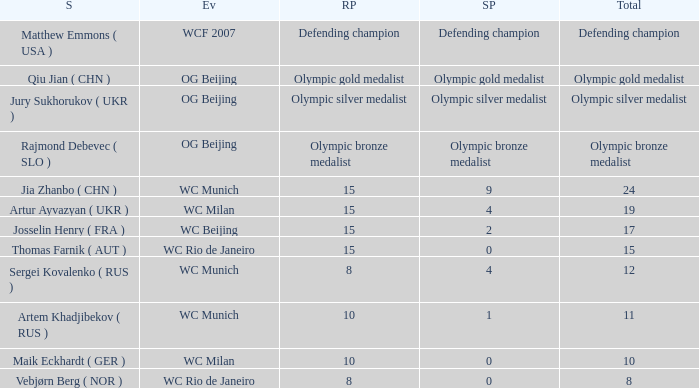Who was the shooter for the WC Beijing event? Josselin Henry ( FRA ). 